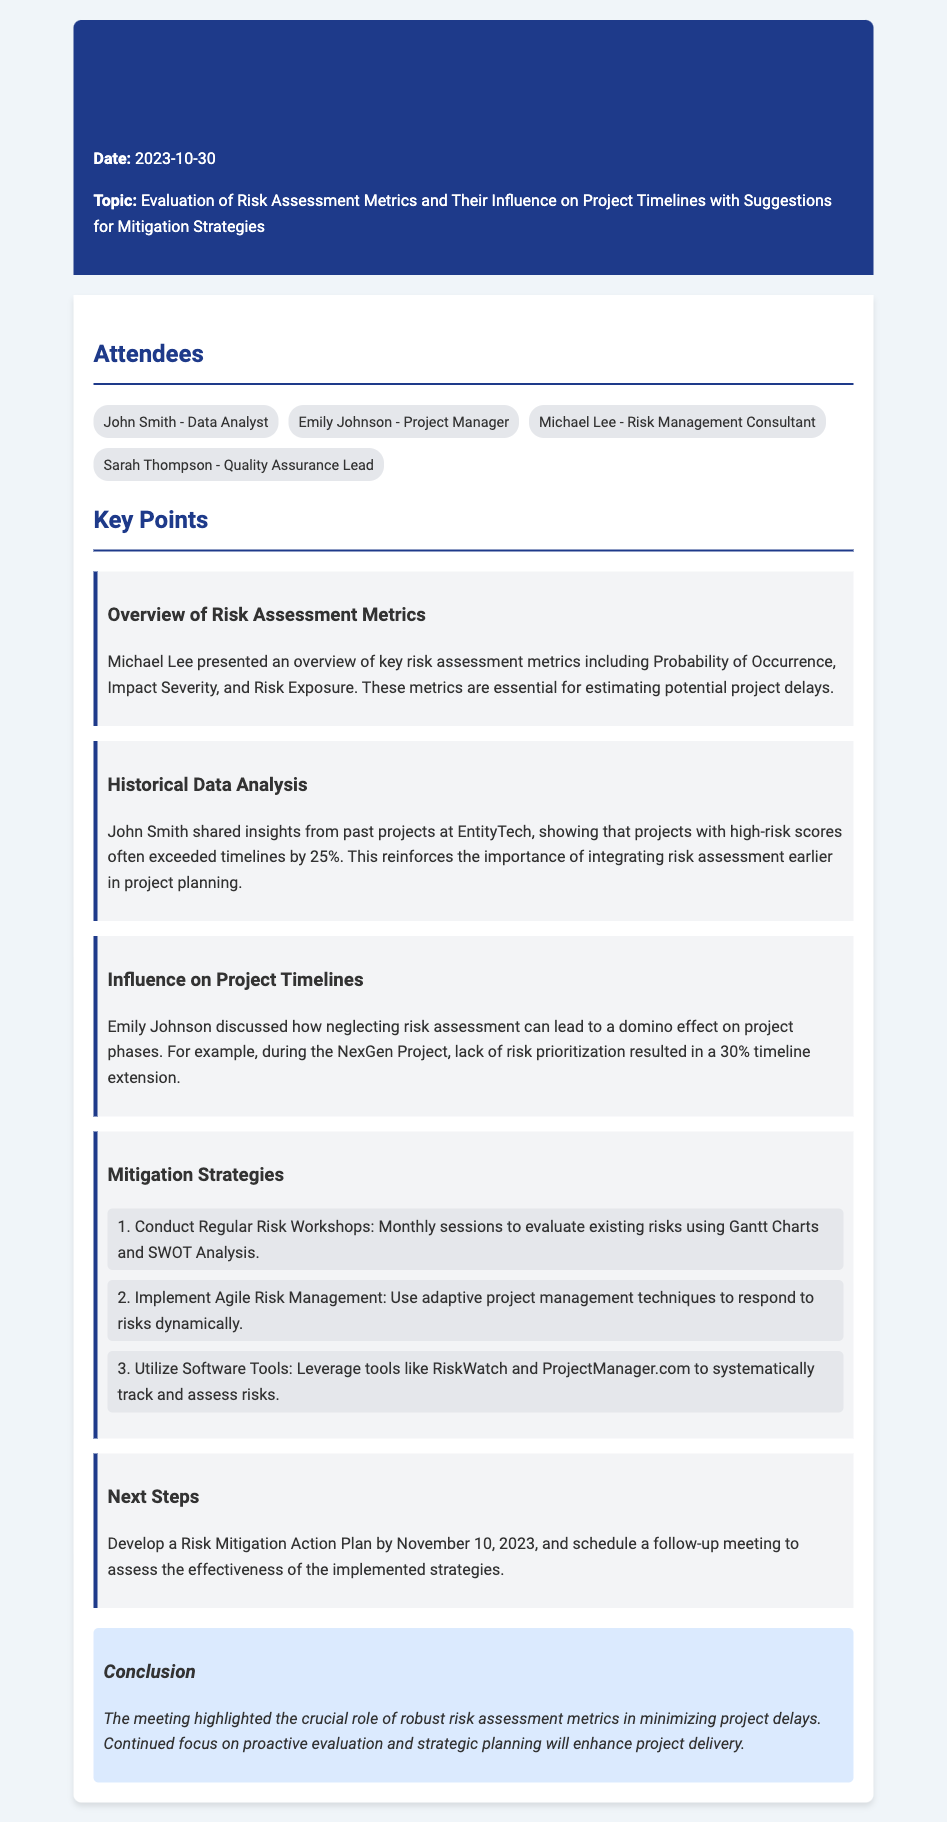What date was the meeting held? The date of the meeting is explicitly mentioned in the header section of the document.
Answer: 2023-10-30 Who presented the overview of key risk assessment metrics? This information is found in the Key Points section, where Michael Lee is identified as the presenter.
Answer: Michael Lee What percentage of timeline extension resulted from the lack of risk prioritization during the NexGen Project? This data point is provided in Emily Johnson's discussion about the influence on project timelines.
Answer: 30% How often should regular risk workshops be conducted? The frequency of the workshops is stated as monthly in the mitigation strategies section.
Answer: Monthly What is the deadline for developing the Risk Mitigation Action Plan? The deadline is specified in the Next Steps section of the document.
Answer: November 10, 2023 What is one of the software tools mentioned for tracking risks? The tools mentioned in the mitigation strategies section provide specific examples of resources for managing risks.
Answer: RiskWatch What role do robust risk assessment metrics play in project timelines? The conclusion summarizes the significance of these metrics in relation to project delivery.
Answer: Minimizing project delays 